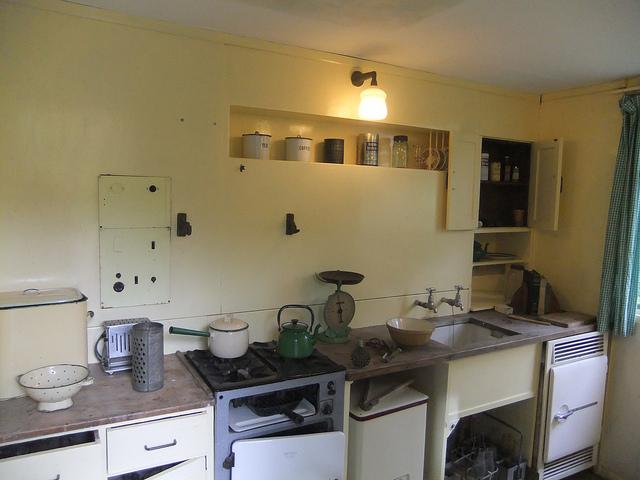What color is the teapot?
Quick response, please. Green. Is there a window in the kitchen?
Concise answer only. Yes. What color is the drawers?
Give a very brief answer. White. What has a dial on it?
Short answer required. Scale. Are all the switches off?
Concise answer only. No. 